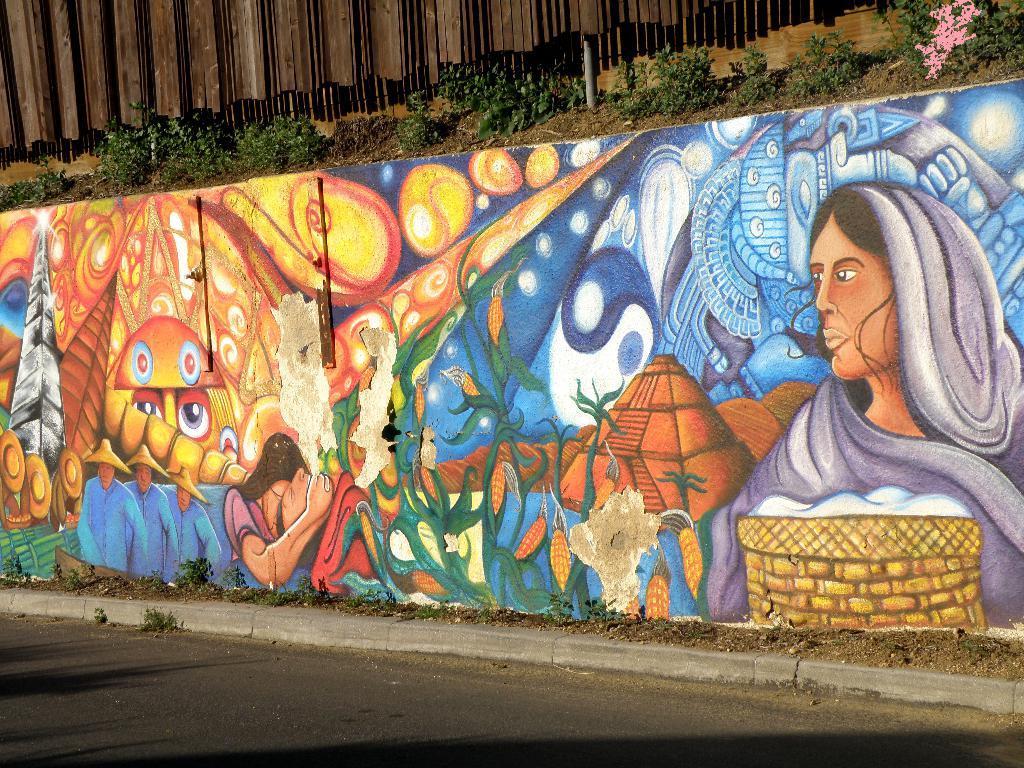In one or two sentences, can you explain what this image depicts? In the image there is a wall and there are beautiful paintings on the wall, above the wall there are small plants. 